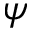Convert formula to latex. <formula><loc_0><loc_0><loc_500><loc_500>\psi</formula> 